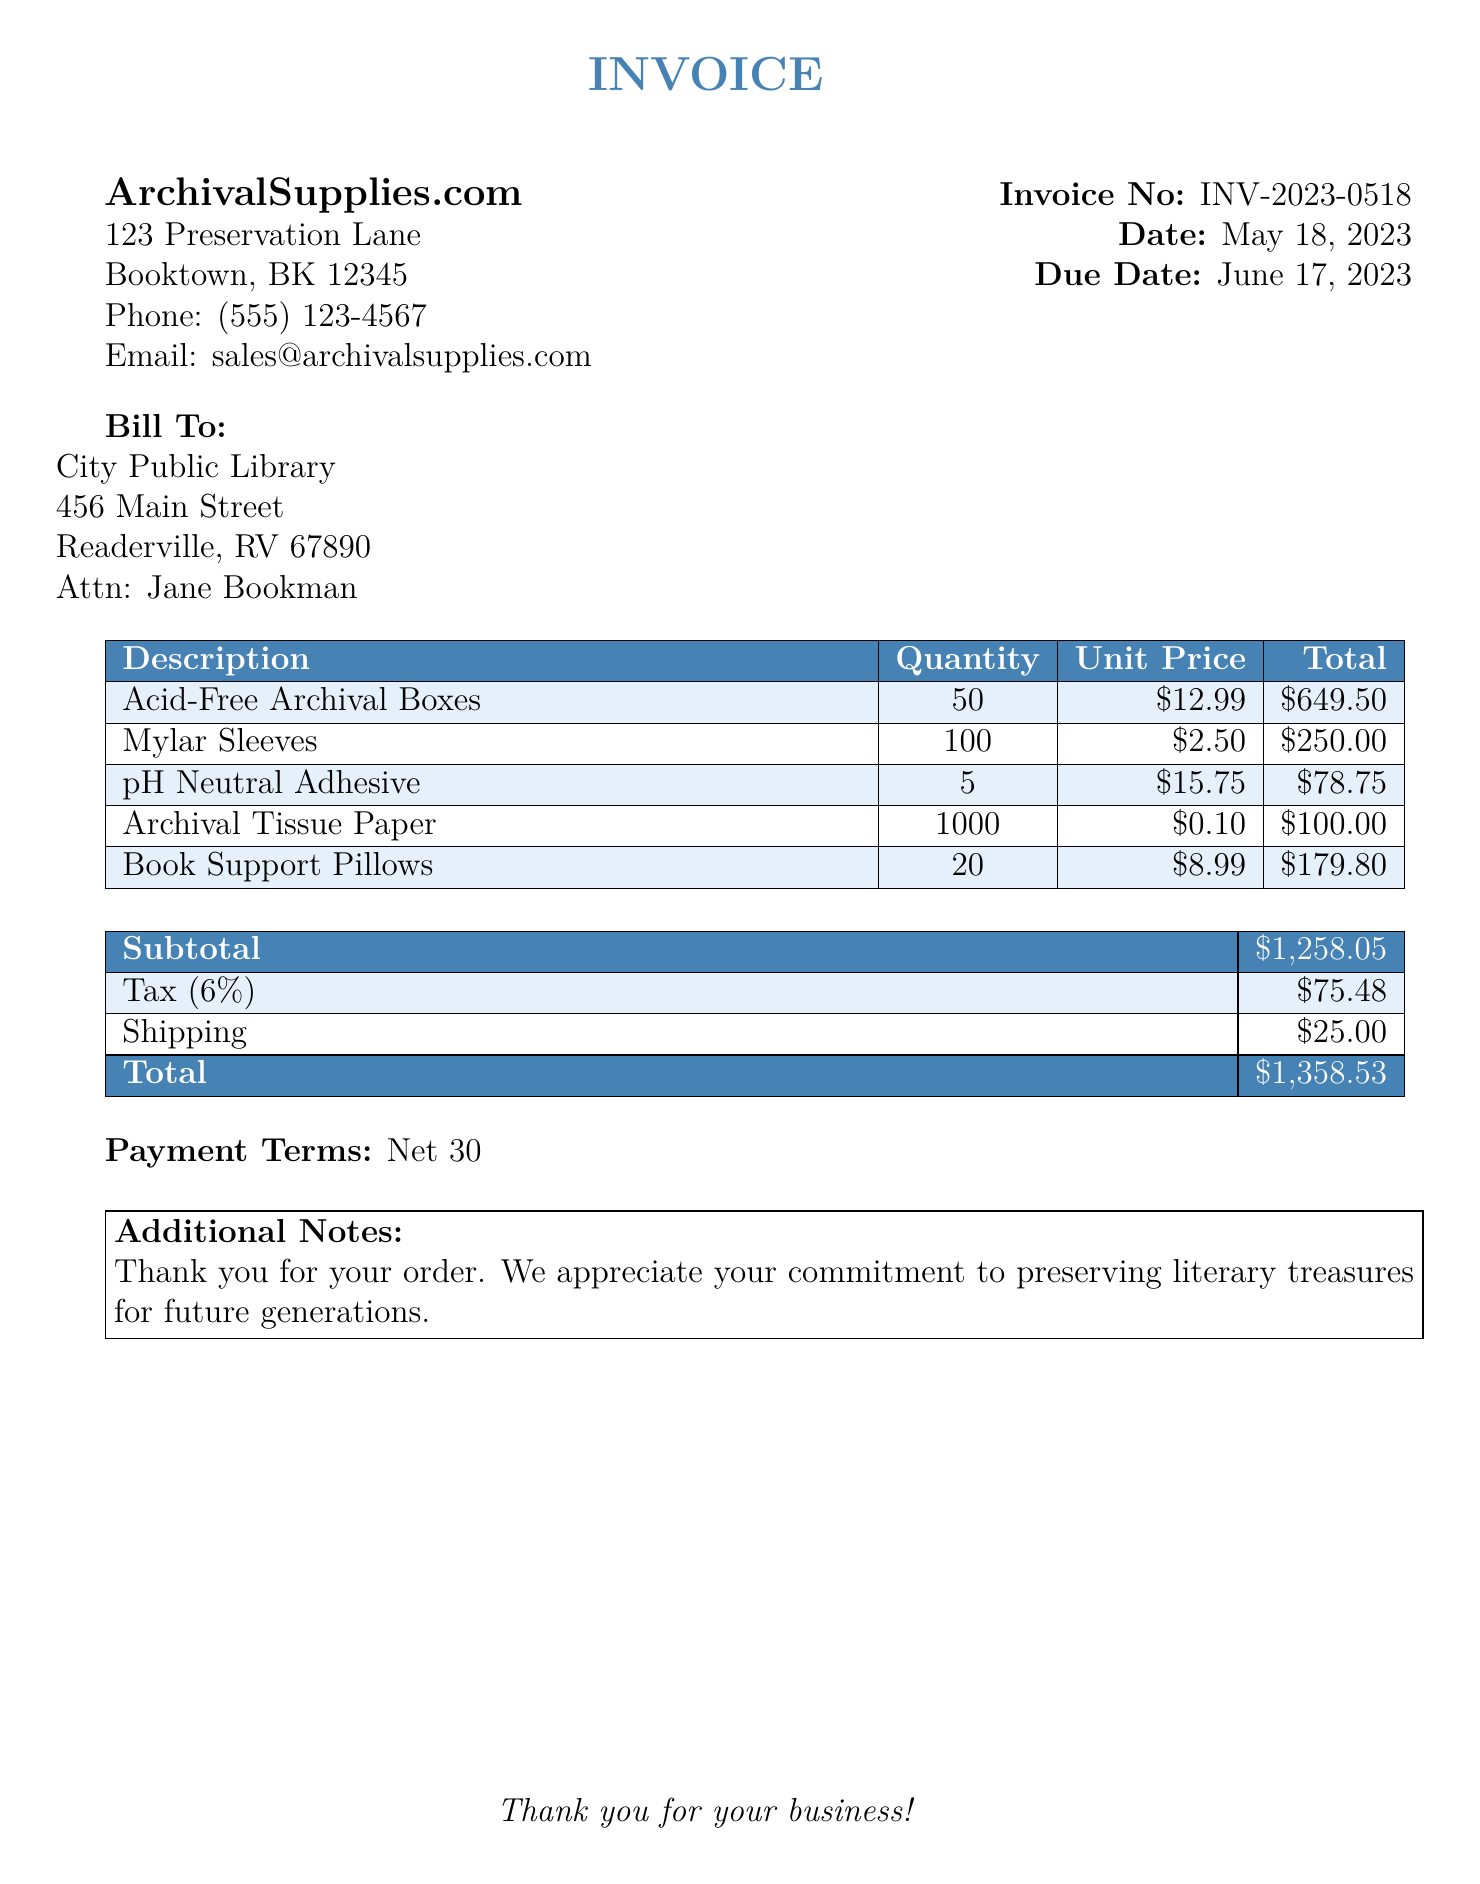What is the name of the supplier? The supplier's name is listed at the top of the document, which is ArchivalSupplies.com.
Answer: ArchivalSupplies.com What is the invoice number? The invoice number can be found near the date section and is denoted as Invoice No.
Answer: INV-2023-0518 When is the due date for the invoice? The due date is specified in the document and is referenced directly.
Answer: June 17, 2023 How many Acid-Free Archival Boxes were ordered? The quantity of Acid-Free Archival Boxes is mentioned in the table under the description column.
Answer: 50 What is the total amount due? The total amount due is located at the end of the document, summing all costs including tax and shipping.
Answer: $1,358.53 What is the tax percentage applied? The tax percentage can be found in the tax line of the total cost table.
Answer: 6% What is the subtotal amount before tax and shipping? The subtotal is clearly marked in the table for quick reference in the document.
Answer: $1,258.05 How many Mylar Sleeves were included in the order? The quantity of Mylar Sleeves is listed in the order details section.
Answer: 100 What is the shipping cost for the order? The shipping cost is specified in the totals table of the invoice.
Answer: $25.00 What are the payment terms indicated? The payment terms can be found in their own section and provide information on when payment is due.
Answer: Net 30 